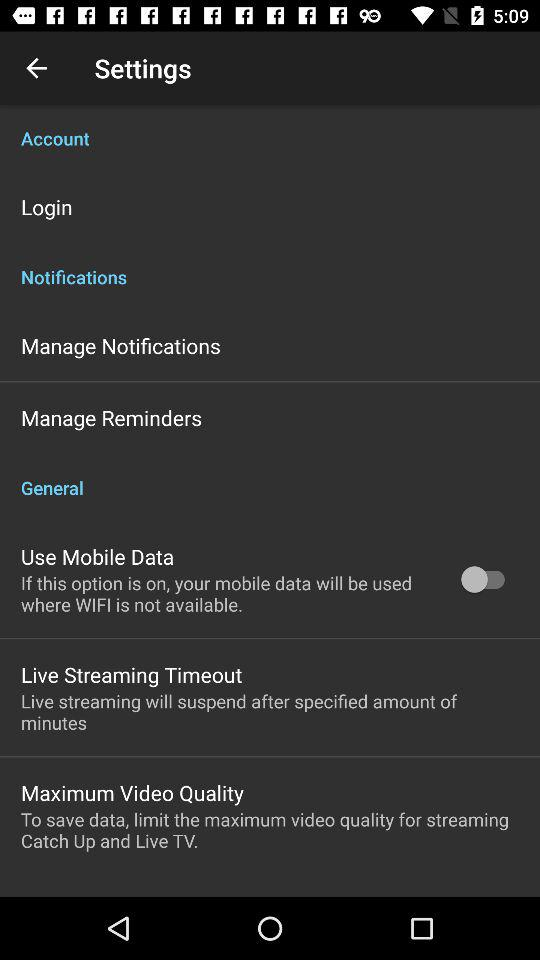What is the status of "Use Mobile Data"? The status of "Use Mobile Data" is "off". 